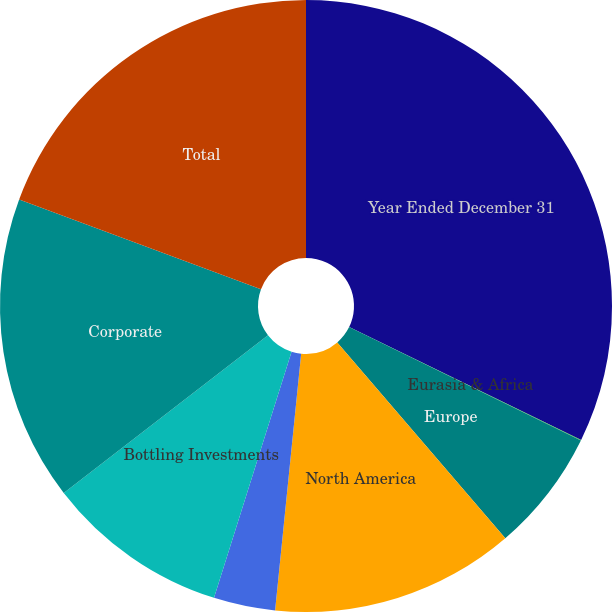Convert chart to OTSL. <chart><loc_0><loc_0><loc_500><loc_500><pie_chart><fcel>Year Ended December 31<fcel>Eurasia & Africa<fcel>Europe<fcel>North America<fcel>Asia Pacific<fcel>Bottling Investments<fcel>Corporate<fcel>Total<nl><fcel>32.21%<fcel>0.03%<fcel>6.47%<fcel>12.9%<fcel>3.25%<fcel>9.68%<fcel>16.12%<fcel>19.34%<nl></chart> 